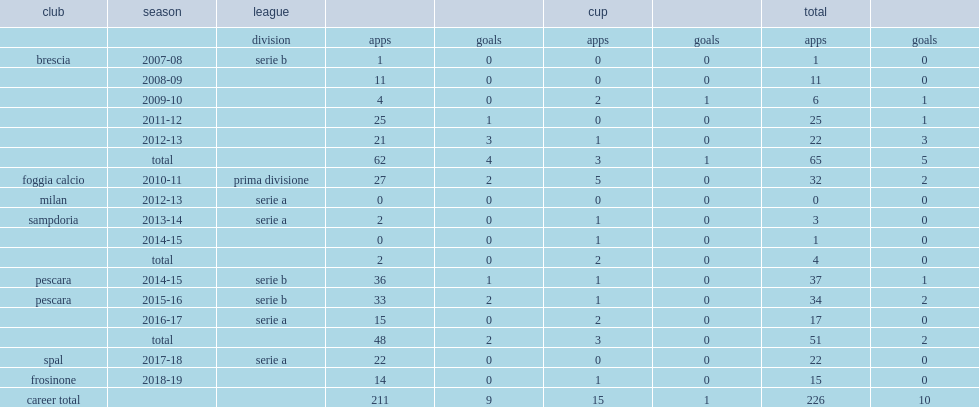Which club did bartosz salamon return to for the 2011-12 season? Brescia. 